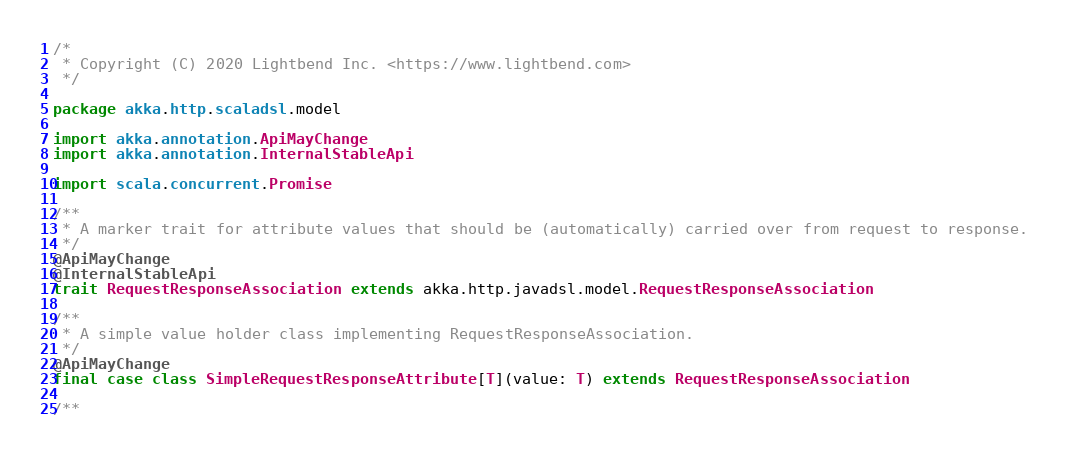<code> <loc_0><loc_0><loc_500><loc_500><_Scala_>/*
 * Copyright (C) 2020 Lightbend Inc. <https://www.lightbend.com>
 */

package akka.http.scaladsl.model

import akka.annotation.ApiMayChange
import akka.annotation.InternalStableApi

import scala.concurrent.Promise

/**
 * A marker trait for attribute values that should be (automatically) carried over from request to response.
 */
@ApiMayChange
@InternalStableApi
trait RequestResponseAssociation extends akka.http.javadsl.model.RequestResponseAssociation

/**
 * A simple value holder class implementing RequestResponseAssociation.
 */
@ApiMayChange
final case class SimpleRequestResponseAttribute[T](value: T) extends RequestResponseAssociation

/**</code> 